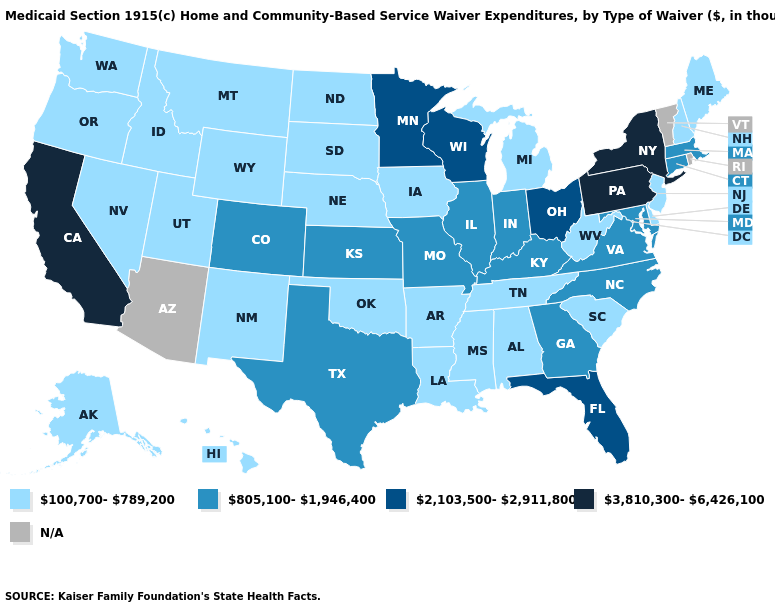What is the value of Massachusetts?
Short answer required. 805,100-1,946,400. Name the states that have a value in the range N/A?
Answer briefly. Arizona, Rhode Island, Vermont. Does California have the highest value in the USA?
Short answer required. Yes. What is the highest value in states that border North Dakota?
Be succinct. 2,103,500-2,911,800. What is the value of Idaho?
Write a very short answer. 100,700-789,200. Name the states that have a value in the range 100,700-789,200?
Give a very brief answer. Alabama, Alaska, Arkansas, Delaware, Hawaii, Idaho, Iowa, Louisiana, Maine, Michigan, Mississippi, Montana, Nebraska, Nevada, New Hampshire, New Jersey, New Mexico, North Dakota, Oklahoma, Oregon, South Carolina, South Dakota, Tennessee, Utah, Washington, West Virginia, Wyoming. Among the states that border Florida , does Georgia have the lowest value?
Be succinct. No. Name the states that have a value in the range 805,100-1,946,400?
Keep it brief. Colorado, Connecticut, Georgia, Illinois, Indiana, Kansas, Kentucky, Maryland, Massachusetts, Missouri, North Carolina, Texas, Virginia. What is the value of North Dakota?
Concise answer only. 100,700-789,200. Name the states that have a value in the range N/A?
Give a very brief answer. Arizona, Rhode Island, Vermont. Which states hav the highest value in the South?
Be succinct. Florida. Name the states that have a value in the range 3,810,300-6,426,100?
Answer briefly. California, New York, Pennsylvania. Which states have the highest value in the USA?
Quick response, please. California, New York, Pennsylvania. What is the highest value in the West ?
Answer briefly. 3,810,300-6,426,100. 